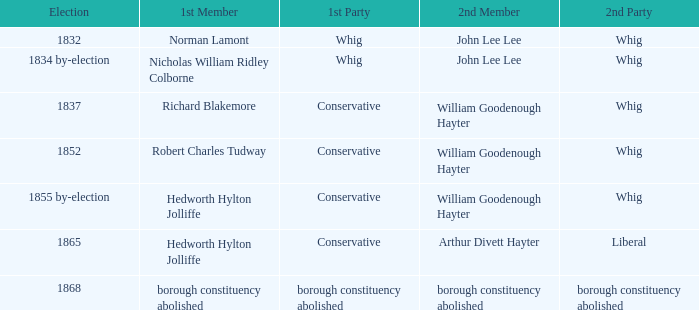What is the second affiliation of the second participant william goodenough hayter when the primary individual is hedworth hylton jolliffe? Whig. 